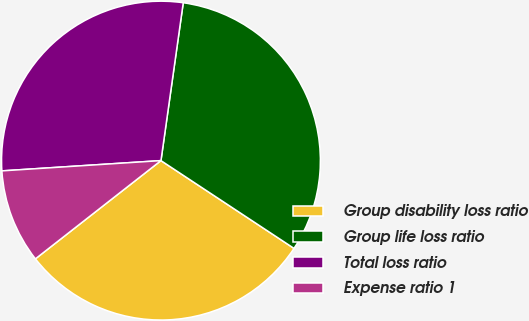Convert chart. <chart><loc_0><loc_0><loc_500><loc_500><pie_chart><fcel>Group disability loss ratio<fcel>Group life loss ratio<fcel>Total loss ratio<fcel>Expense ratio 1<nl><fcel>30.15%<fcel>32.05%<fcel>28.26%<fcel>9.54%<nl></chart> 